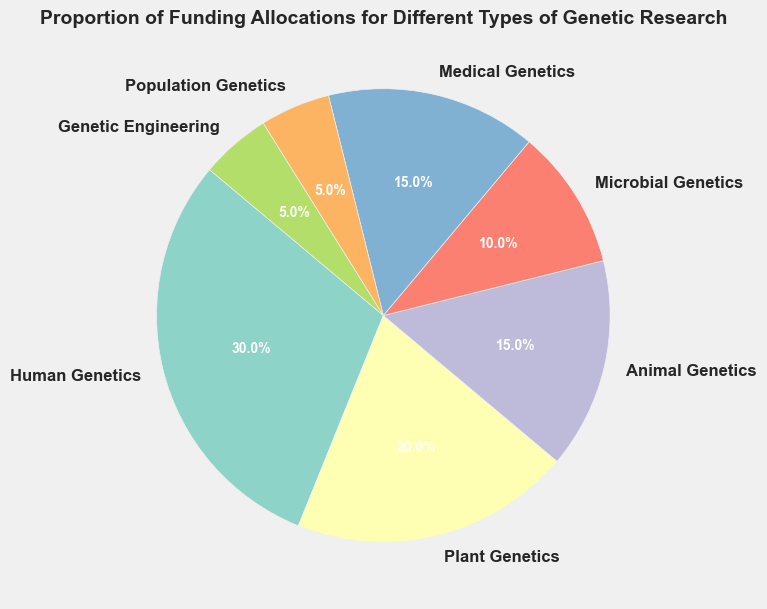Which type of genetic research has the highest proportion of funding? The largest slice in the pie chart represents Human Genetics, which is labeled with 30%. Therefore, Human Genetics has the highest proportion of funding.
Answer: Human Genetics What is the combined proportion of funding for Medical Genetics and Animal Genetics? Identify the slices representing Medical Genetics and Animal Genetics, which are labeled 15% and 15% respectively. Add these two values: 15% + 15% = 30%.
Answer: 30% Which type of genetic research receives less funding: Microbial Genetics or Population Genetics? Compare the slices labeled Microbial Genetics (10%) and Population Genetics (5%). Since 5% is less than 10%, Population Genetics receives less funding.
Answer: Population Genetics How does the proportion of funding for Plant Genetics compare to Genetic Engineering? Identify the slices for Plant Genetics (20%) and Genetic Engineering (5%). Compare these values: 20% is greater than 5%, so Plant Genetics receives more funding than Genetic Engineering.
Answer: Plant Genetics Is the proportion of funding for Population Genetics equal to Genetic Engineering? Identify both slices and their labels: Population Genetics is 5% and Genetic Engineering is also 5%. Since both are equal, the funding proportion is the same.
Answer: Yes What is the total proportion of funding for all types of genetic research shown in the chart? Add the proportions of all types of genetic research: 30% (Human Genetics) + 20% (Plant Genetics) + 15% (Animal Genetics) + 10% (Microbial Genetics) + 15% (Medical Genetics) + 5% (Population Genetics) + 5% (Genetic Engineering). The total is 100%.
Answer: 100% By how much does the proportion of funding for Human Genetics exceed Microbial Genetics? Identify the proportions for Human Genetics (30%) and Microbial Genetics (10%). Subtract Microbial Genetics from Human Genetics: 30% - 10% = 20%.
Answer: 20% What is the average proportion of funding per type of genetic research? There are seven categories of genetic research. Sum their proportions: 30% + 20% + 15% + 10% + 15% + 5% + 5% = 100%. Divide by the number of categories: 100% / 7 ≈ 14.29%.
Answer: 14.29% Which categories have exactly the same proportion of funding? Identify and compare the proportions of each category. Both Animal Genetics and Medical Genetics are labeled with 15%, and Population Genetics and Genetic Engineering are labeled with 5%. Two pairs have the same proportion: Animal Genetics & Medical Genetics, Population Genetics & Genetic Engineering.
Answer: Animal Genetics & Medical Genetics, Population Genetics & Genetic Engineering 